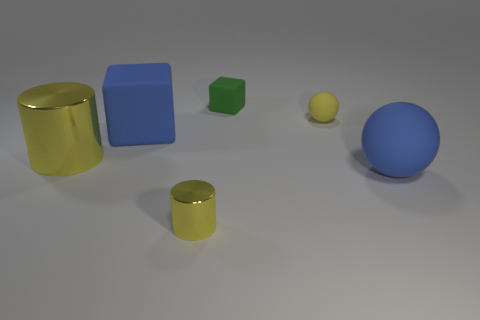There is another matte thing that is the same shape as the green object; what is its color?
Offer a very short reply. Blue. What is the color of the big shiny thing?
Make the answer very short. Yellow. Is the big cylinder the same color as the tiny metallic object?
Give a very brief answer. Yes. Are there any matte blocks on the right side of the small thing in front of the big yellow metallic thing?
Keep it short and to the point. Yes. How many objects are either things that are in front of the yellow rubber thing or small metal things that are in front of the blue cube?
Make the answer very short. 4. What number of objects are big blue objects or rubber objects that are in front of the green block?
Provide a short and direct response. 3. How big is the blue rubber thing behind the yellow cylinder to the left of the metallic object in front of the blue rubber ball?
Offer a terse response. Large. There is a block that is the same size as the yellow matte object; what material is it?
Your answer should be compact. Rubber. Is there a block of the same size as the yellow matte ball?
Provide a succinct answer. Yes. There is a blue rubber object in front of the blue block; is it the same size as the large metallic cylinder?
Provide a short and direct response. Yes. 